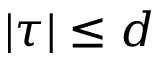<formula> <loc_0><loc_0><loc_500><loc_500>| \tau | \leq d</formula> 